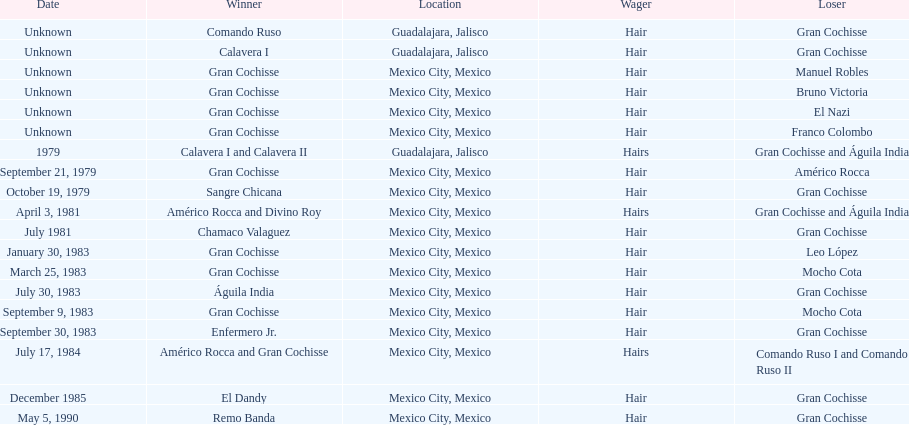How many games more than chamaco valaguez did sangre chicana win? 0. 